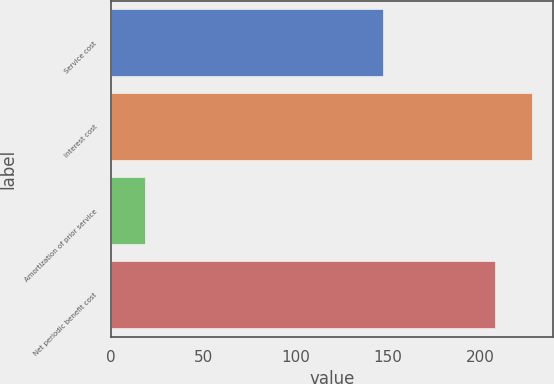Convert chart. <chart><loc_0><loc_0><loc_500><loc_500><bar_chart><fcel>Service cost<fcel>Interest cost<fcel>Amortization of prior service<fcel>Net periodic benefit cost<nl><fcel>147<fcel>227.7<fcel>18<fcel>208<nl></chart> 